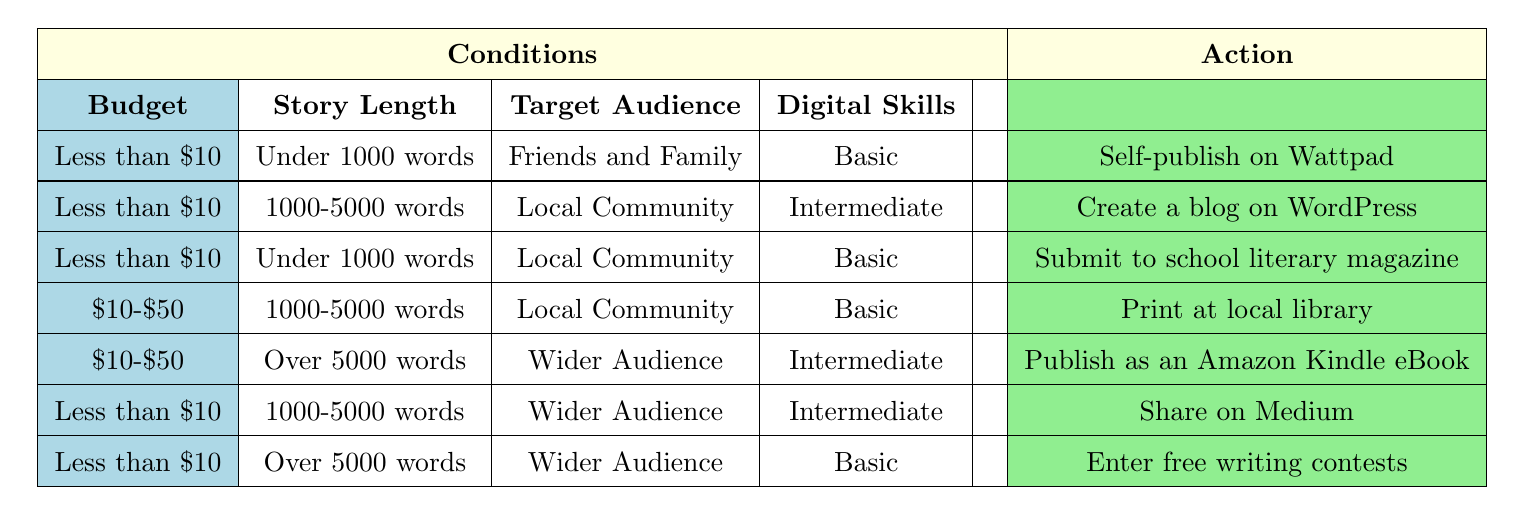What is the recommended publishing method for a story under 1000 words targeting friends and family on a budget less than $10? According to the table, for a budget less than $10, if the story is under 1000 words and the target audience is friends and family, the recommended action is to "Self-publish on Wattpad."
Answer: Self-publish on Wattpad How many publishing methods are available for stories over 5000 words? The table shows that there are two options for stories over 5000 words: "Publish as an Amazon Kindle eBook" and "Enter free writing contests." Therefore, there are two publishing methods available.
Answer: 2 If I have a budget between $10 and $50, what options do I have for stories of 1000-5000 words aimed at the local community? The only option listed for a budget of $10-$50, with a story length of 1000-5000 words, and targeting the local community is "Print at local library."
Answer: Print at local library Are there any publishing methods that require intermediate digital skills? Yes, there are several methods that require intermediate digital skills: "Create a blog on WordPress," "Publish as an Amazon Kindle eBook," and "Share on Medium."
Answer: Yes Which publishing method would you choose if you want to share a story of 1000-5000 words targeting a wider audience on a budget under $10? In the table, the action for a story of 1000-5000 words, targeting a wider audience with a budget less than $10 is "Share on Medium."
Answer: Share on Medium What is the publishing action for a story over 5000 words targeting a local community with basic digital skills? The table indicates that there is no action listed for a story over 5000 words with a local community target and basic digital skills; thus, no options are available under those conditions.
Answer: No options available If a story is under 1000 words and the target audience is a wider audience with basic skills, what is the recommended action? The table shows that there is no direct match for a story under 1000 words, with a target audience of a wider audience and basic skills; therefore, there is no recommended action for those criteria.
Answer: No recommended action What is the difference in the number of options available for a budget less than $10 versus a budget between $10 and $50? Options under $10 include "Self-publish on Wattpad," "Create a blog on WordPress," "Submit to school literary magazine," "Share on Medium," and "Enter free writing contests," totaling 5 options. For a budget between $10 and $50, there are only 2 options: "Print at local library" and "Publish as an Amazon Kindle eBook." The difference is 5 - 2 = 3.
Answer: 3 If I have advanced digital skills, can I self-publish a story of any length targeting my friends and family on a budget less than $10? The table specifies that for the conditions of a budget less than $10, the story must be under 1000 words for the friends and family target, and there is only a matching action for that. Thus, advanced skills are not needed for this choice.
Answer: Yes 